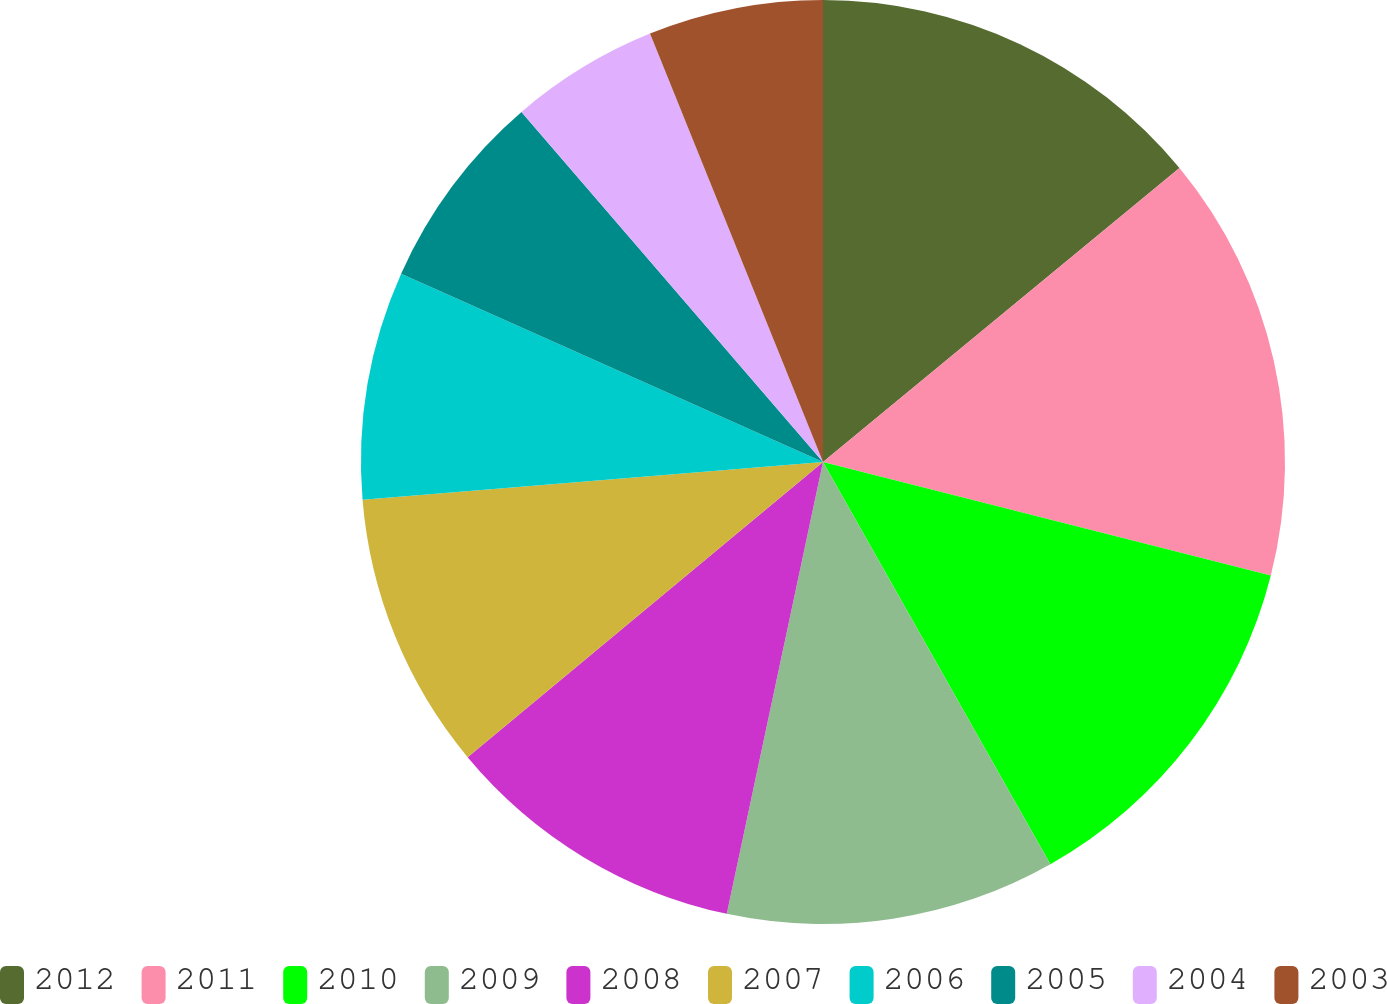Convert chart. <chart><loc_0><loc_0><loc_500><loc_500><pie_chart><fcel>2012<fcel>2011<fcel>2010<fcel>2009<fcel>2008<fcel>2007<fcel>2006<fcel>2005<fcel>2004<fcel>2003<nl><fcel>14.03%<fcel>14.93%<fcel>12.86%<fcel>11.53%<fcel>10.63%<fcel>9.73%<fcel>7.99%<fcel>7.0%<fcel>5.21%<fcel>6.11%<nl></chart> 